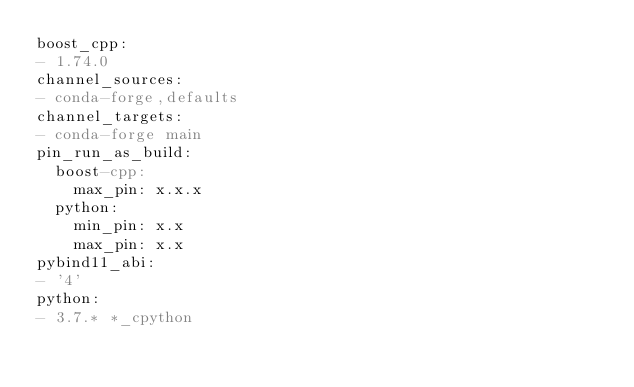<code> <loc_0><loc_0><loc_500><loc_500><_YAML_>boost_cpp:
- 1.74.0
channel_sources:
- conda-forge,defaults
channel_targets:
- conda-forge main
pin_run_as_build:
  boost-cpp:
    max_pin: x.x.x
  python:
    min_pin: x.x
    max_pin: x.x
pybind11_abi:
- '4'
python:
- 3.7.* *_cpython</code> 